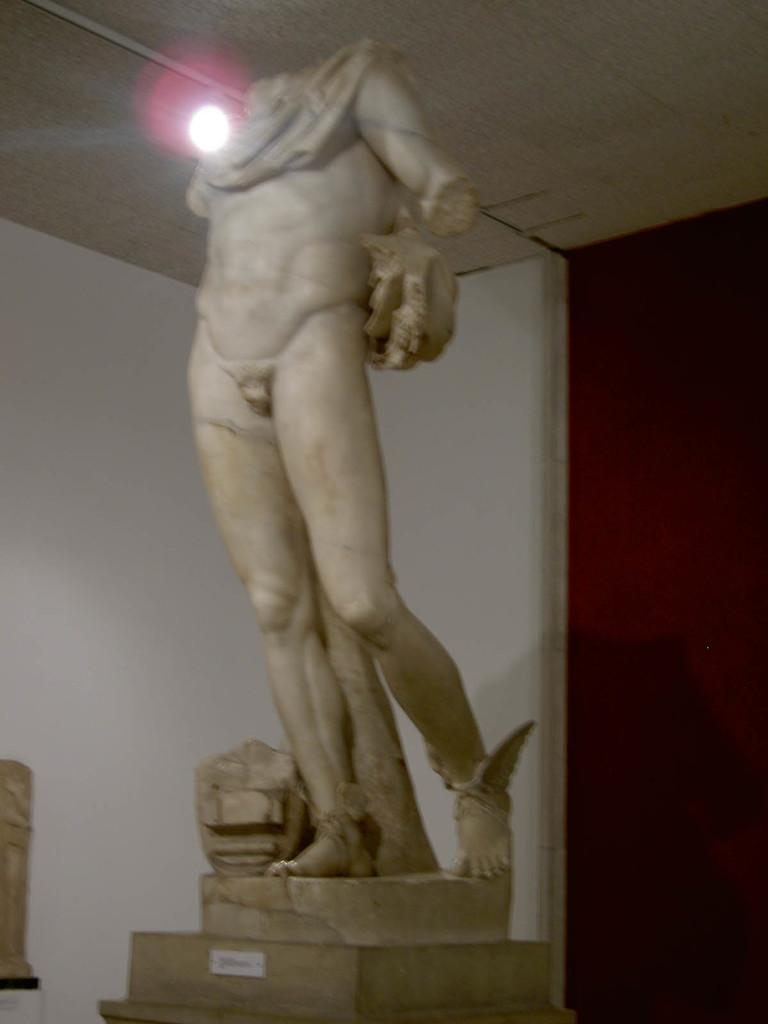What is the main subject of the image? There is a statue on a pillar in the image. What can be seen in the background of the image? There is a wall in the background of the image. What is above the statue in the image? There is a ceiling visible in the image. What is providing illumination in the image? There is: There is a light in the image. What type of sock is the man wearing in the image? There is no man present in the image, so it is not possible to determine what type of sock he might be wearing. 